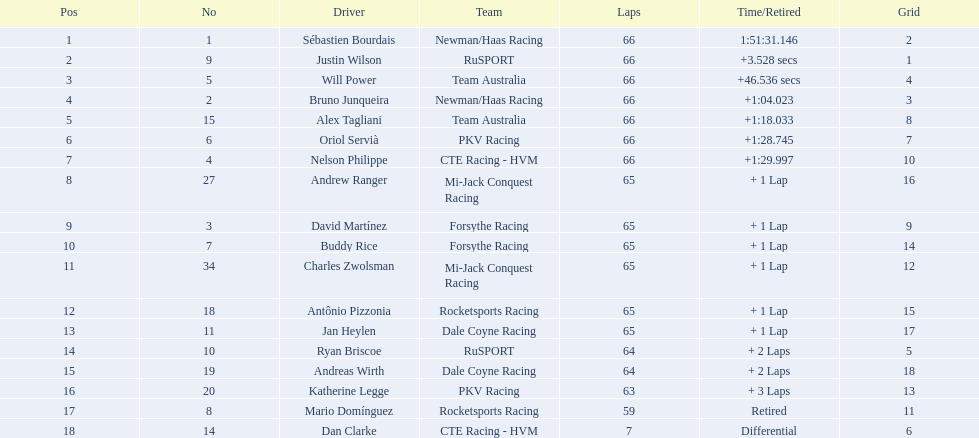What are the names of the drivers who were in position 14 through position 18? Ryan Briscoe, Andreas Wirth, Katherine Legge, Mario Domínguez, Dan Clarke. Of these , which ones didn't finish due to retired or differential? Mario Domínguez, Dan Clarke. Which one of the previous drivers retired? Mario Domínguez. Which of the drivers in question 2 had a differential? Dan Clarke. How many laps did oriol servia complete at the 2006 gran premio? 66. How many laps did katherine legge complete at the 2006 gran premio? 63. Between servia and legge, who completed more laps? Oriol Servià. 